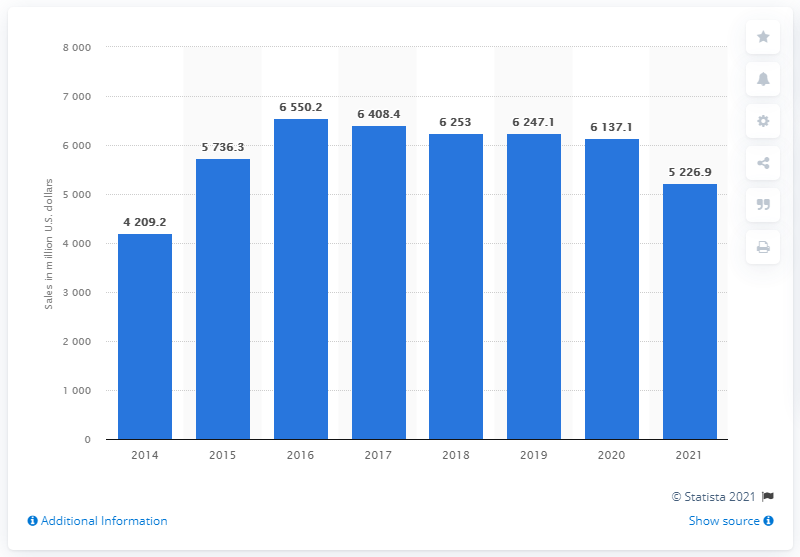Identify some key points in this picture. In 2021, the global net sales of Signet Jewelers were 5,226.9 million dollars. 